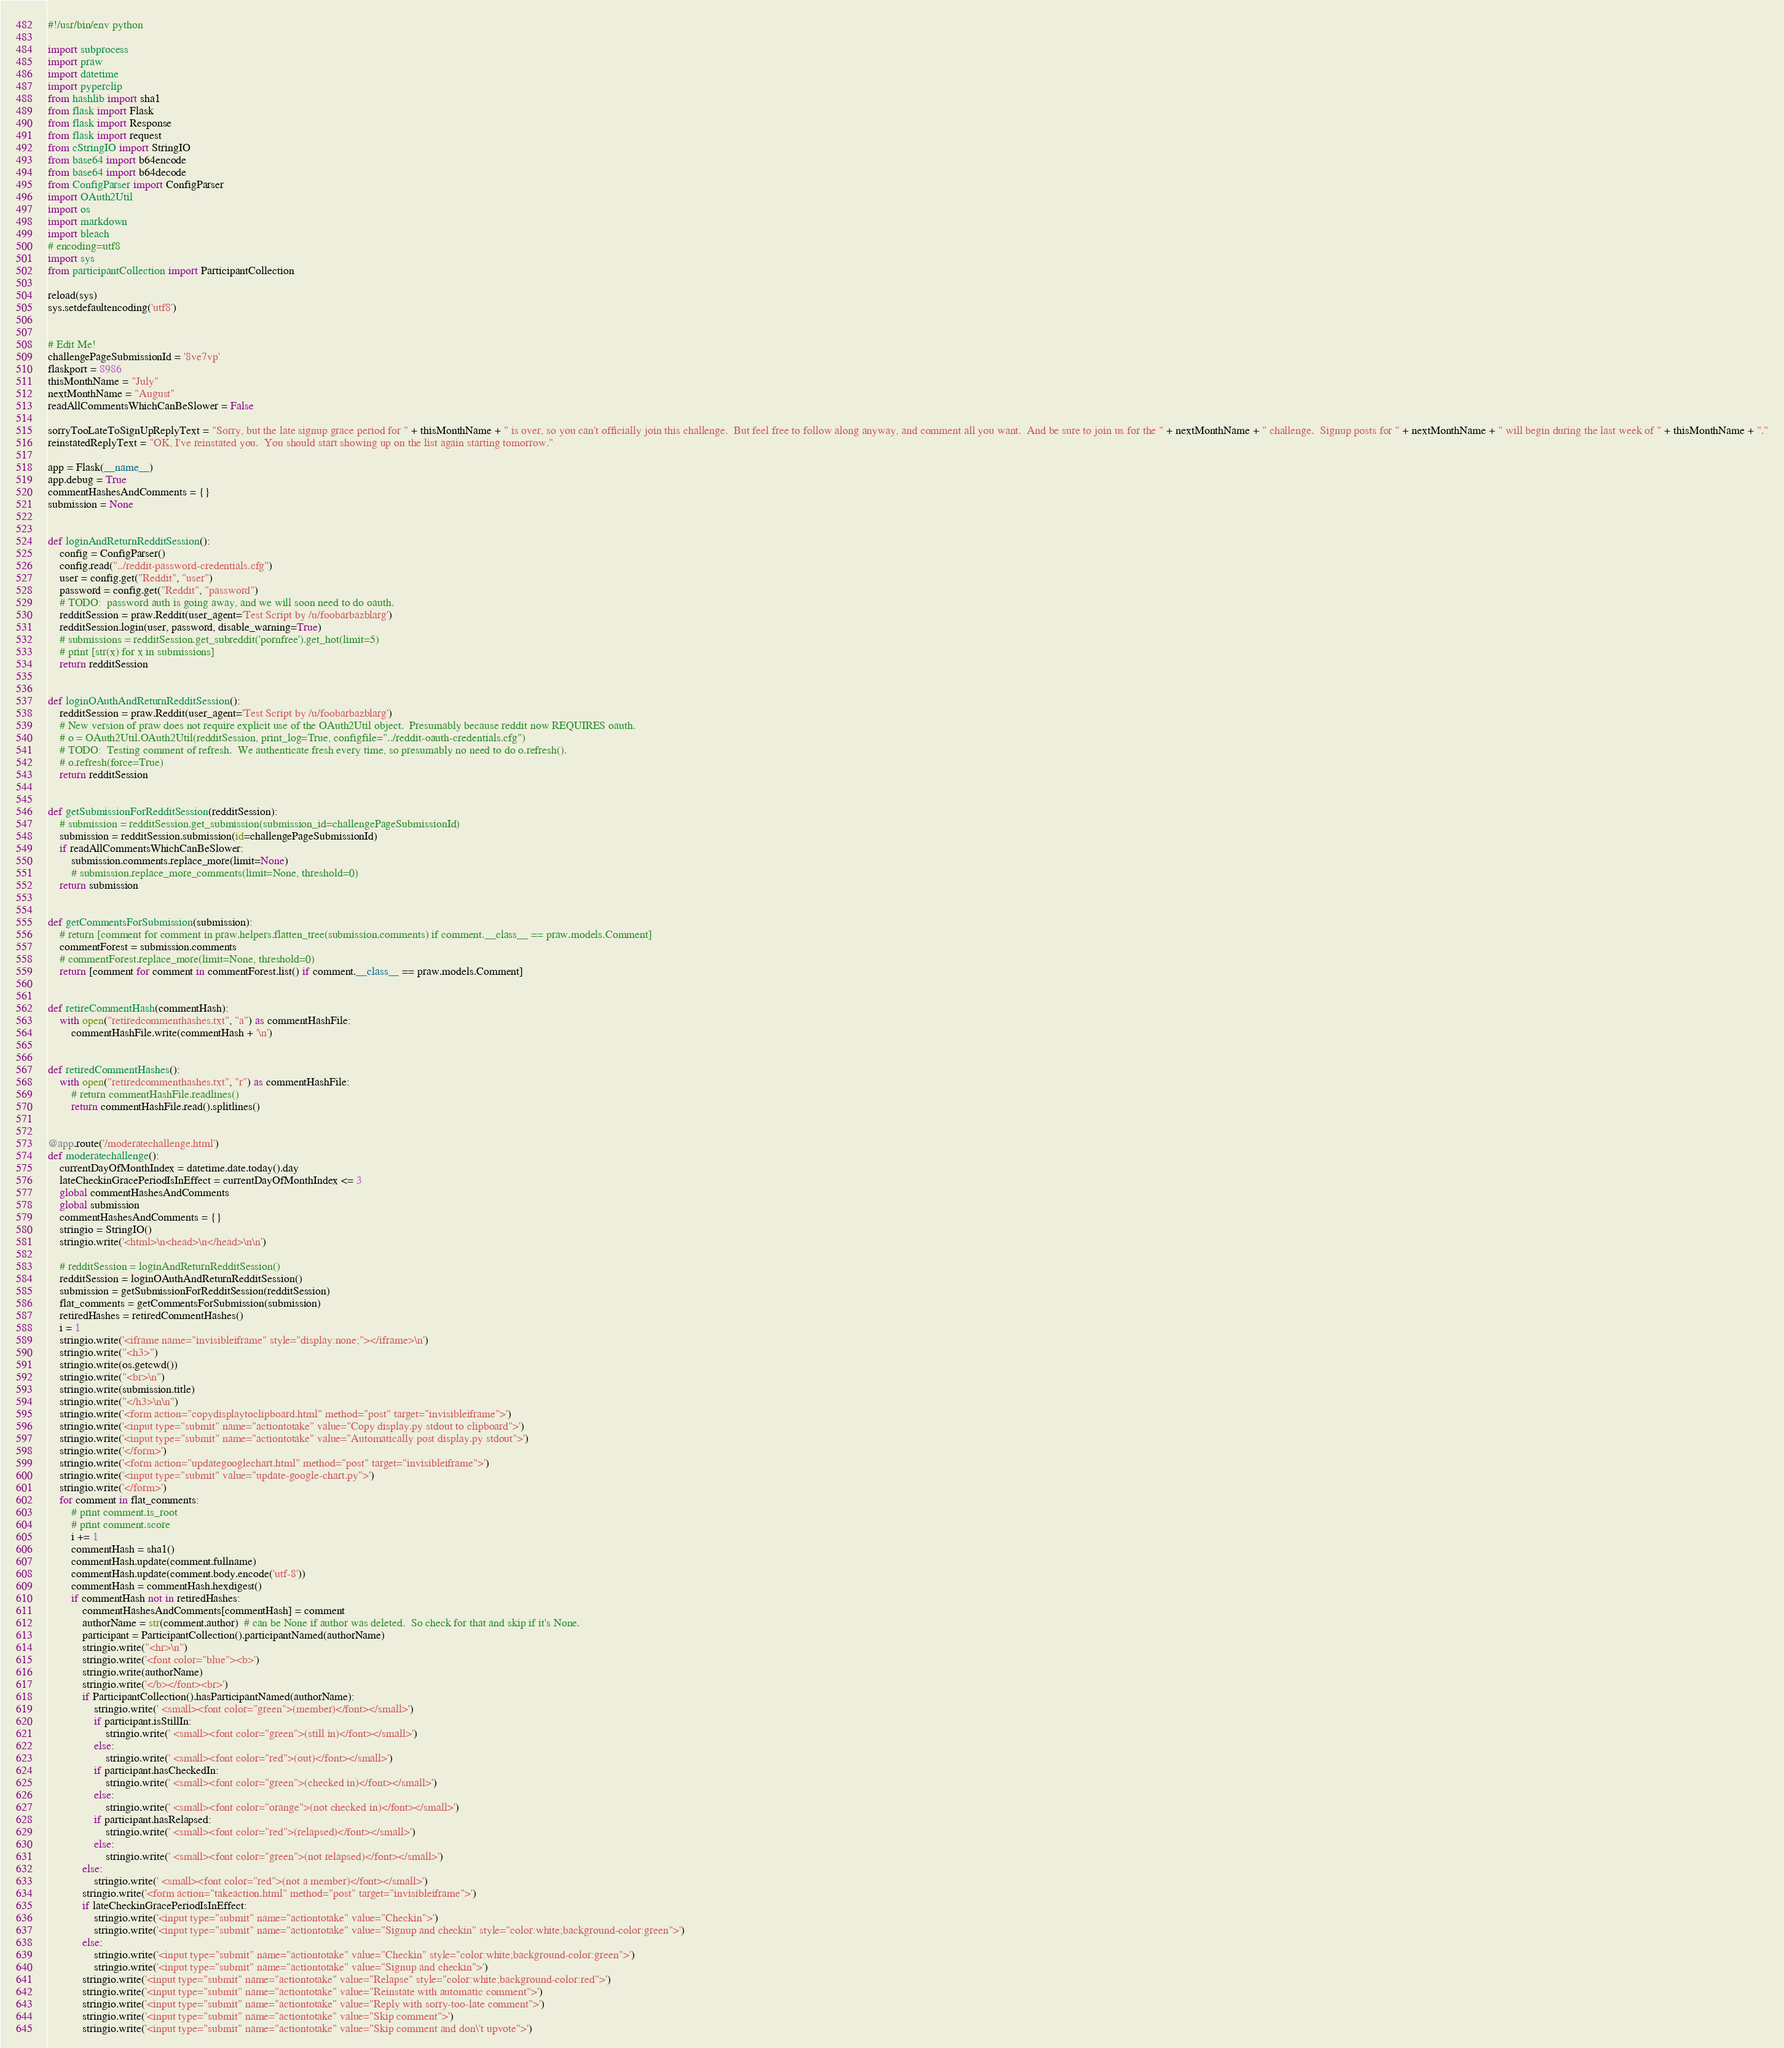<code> <loc_0><loc_0><loc_500><loc_500><_Python_>#!/usr/bin/env python

import subprocess
import praw
import datetime
import pyperclip
from hashlib import sha1
from flask import Flask
from flask import Response
from flask import request
from cStringIO import StringIO
from base64 import b64encode
from base64 import b64decode
from ConfigParser import ConfigParser
import OAuth2Util
import os
import markdown
import bleach
# encoding=utf8
import sys
from participantCollection import ParticipantCollection

reload(sys)
sys.setdefaultencoding('utf8')


# Edit Me!
challengePageSubmissionId = '8ve7vp'
flaskport = 8986
thisMonthName = "July"
nextMonthName = "August"
readAllCommentsWhichCanBeSlower = False

sorryTooLateToSignUpReplyText = "Sorry, but the late signup grace period for " + thisMonthName + " is over, so you can't officially join this challenge.  But feel free to follow along anyway, and comment all you want.  And be sure to join us for the " + nextMonthName + " challenge.  Signup posts for " + nextMonthName + " will begin during the last week of " + thisMonthName + "."
reinstatedReplyText = "OK, I've reinstated you.  You should start showing up on the list again starting tomorrow."

app = Flask(__name__)
app.debug = True
commentHashesAndComments = {}
submission = None


def loginAndReturnRedditSession():
    config = ConfigParser()
    config.read("../reddit-password-credentials.cfg")
    user = config.get("Reddit", "user")
    password = config.get("Reddit", "password")
    # TODO:  password auth is going away, and we will soon need to do oauth.
    redditSession = praw.Reddit(user_agent='Test Script by /u/foobarbazblarg')
    redditSession.login(user, password, disable_warning=True)
    # submissions = redditSession.get_subreddit('pornfree').get_hot(limit=5)
    # print [str(x) for x in submissions]
    return redditSession


def loginOAuthAndReturnRedditSession():
    redditSession = praw.Reddit(user_agent='Test Script by /u/foobarbazblarg')
    # New version of praw does not require explicit use of the OAuth2Util object.  Presumably because reddit now REQUIRES oauth.
    # o = OAuth2Util.OAuth2Util(redditSession, print_log=True, configfile="../reddit-oauth-credentials.cfg")
    # TODO:  Testing comment of refresh.  We authenticate fresh every time, so presumably no need to do o.refresh().
    # o.refresh(force=True)
    return redditSession


def getSubmissionForRedditSession(redditSession):
    # submission = redditSession.get_submission(submission_id=challengePageSubmissionId)
    submission = redditSession.submission(id=challengePageSubmissionId)
    if readAllCommentsWhichCanBeSlower:
        submission.comments.replace_more(limit=None)
        # submission.replace_more_comments(limit=None, threshold=0)
    return submission


def getCommentsForSubmission(submission):
    # return [comment for comment in praw.helpers.flatten_tree(submission.comments) if comment.__class__ == praw.models.Comment]
    commentForest = submission.comments
    # commentForest.replace_more(limit=None, threshold=0)
    return [comment for comment in commentForest.list() if comment.__class__ == praw.models.Comment]


def retireCommentHash(commentHash):
    with open("retiredcommenthashes.txt", "a") as commentHashFile:
        commentHashFile.write(commentHash + '\n')


def retiredCommentHashes():
    with open("retiredcommenthashes.txt", "r") as commentHashFile:
        # return commentHashFile.readlines()
        return commentHashFile.read().splitlines()


@app.route('/moderatechallenge.html')
def moderatechallenge():
    currentDayOfMonthIndex = datetime.date.today().day
    lateCheckinGracePeriodIsInEffect = currentDayOfMonthIndex <= 3
    global commentHashesAndComments
    global submission
    commentHashesAndComments = {}
    stringio = StringIO()
    stringio.write('<html>\n<head>\n</head>\n\n')

    # redditSession = loginAndReturnRedditSession()
    redditSession = loginOAuthAndReturnRedditSession()
    submission = getSubmissionForRedditSession(redditSession)
    flat_comments = getCommentsForSubmission(submission)
    retiredHashes = retiredCommentHashes()
    i = 1
    stringio.write('<iframe name="invisibleiframe" style="display:none;"></iframe>\n')
    stringio.write("<h3>")
    stringio.write(os.getcwd())
    stringio.write("<br>\n")
    stringio.write(submission.title)
    stringio.write("</h3>\n\n")
    stringio.write('<form action="copydisplaytoclipboard.html" method="post" target="invisibleiframe">')
    stringio.write('<input type="submit" name="actiontotake" value="Copy display.py stdout to clipboard">')
    stringio.write('<input type="submit" name="actiontotake" value="Automatically post display.py stdout">')
    stringio.write('</form>')
    stringio.write('<form action="updategooglechart.html" method="post" target="invisibleiframe">')
    stringio.write('<input type="submit" value="update-google-chart.py">')
    stringio.write('</form>')
    for comment in flat_comments:
        # print comment.is_root
        # print comment.score
        i += 1
        commentHash = sha1()
        commentHash.update(comment.fullname)
        commentHash.update(comment.body.encode('utf-8'))
        commentHash = commentHash.hexdigest()
        if commentHash not in retiredHashes:
            commentHashesAndComments[commentHash] = comment
            authorName = str(comment.author)  # can be None if author was deleted.  So check for that and skip if it's None.
            participant = ParticipantCollection().participantNamed(authorName)
            stringio.write("<hr>\n")
            stringio.write('<font color="blue"><b>')
            stringio.write(authorName)
            stringio.write('</b></font><br>')
            if ParticipantCollection().hasParticipantNamed(authorName):
                stringio.write(' <small><font color="green">(member)</font></small>')
                if participant.isStillIn:
                    stringio.write(' <small><font color="green">(still in)</font></small>')
                else:
                    stringio.write(' <small><font color="red">(out)</font></small>')
                if participant.hasCheckedIn:
                    stringio.write(' <small><font color="green">(checked in)</font></small>')
                else:
                    stringio.write(' <small><font color="orange">(not checked in)</font></small>')
                if participant.hasRelapsed:
                    stringio.write(' <small><font color="red">(relapsed)</font></small>')
                else:
                    stringio.write(' <small><font color="green">(not relapsed)</font></small>')
            else:
                stringio.write(' <small><font color="red">(not a member)</font></small>')
            stringio.write('<form action="takeaction.html" method="post" target="invisibleiframe">')
            if lateCheckinGracePeriodIsInEffect:
                stringio.write('<input type="submit" name="actiontotake" value="Checkin">')
                stringio.write('<input type="submit" name="actiontotake" value="Signup and checkin" style="color:white;background-color:green">')
            else:
                stringio.write('<input type="submit" name="actiontotake" value="Checkin" style="color:white;background-color:green">')
                stringio.write('<input type="submit" name="actiontotake" value="Signup and checkin">')
            stringio.write('<input type="submit" name="actiontotake" value="Relapse" style="color:white;background-color:red">')
            stringio.write('<input type="submit" name="actiontotake" value="Reinstate with automatic comment">')
            stringio.write('<input type="submit" name="actiontotake" value="Reply with sorry-too-late comment">')
            stringio.write('<input type="submit" name="actiontotake" value="Skip comment">')
            stringio.write('<input type="submit" name="actiontotake" value="Skip comment and don\'t upvote">')</code> 